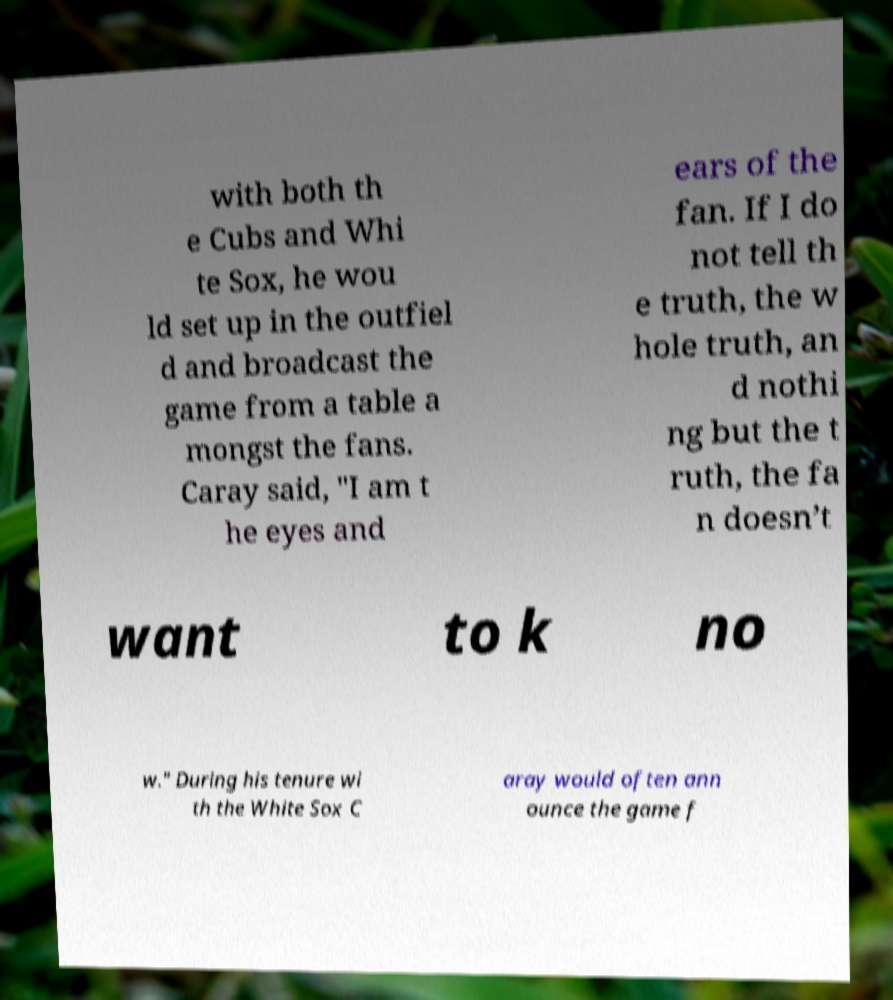Can you read and provide the text displayed in the image?This photo seems to have some interesting text. Can you extract and type it out for me? with both th e Cubs and Whi te Sox, he wou ld set up in the outfiel d and broadcast the game from a table a mongst the fans. Caray said, "I am t he eyes and ears of the fan. If I do not tell th e truth, the w hole truth, an d nothi ng but the t ruth, the fa n doesn’t want to k no w." During his tenure wi th the White Sox C aray would often ann ounce the game f 